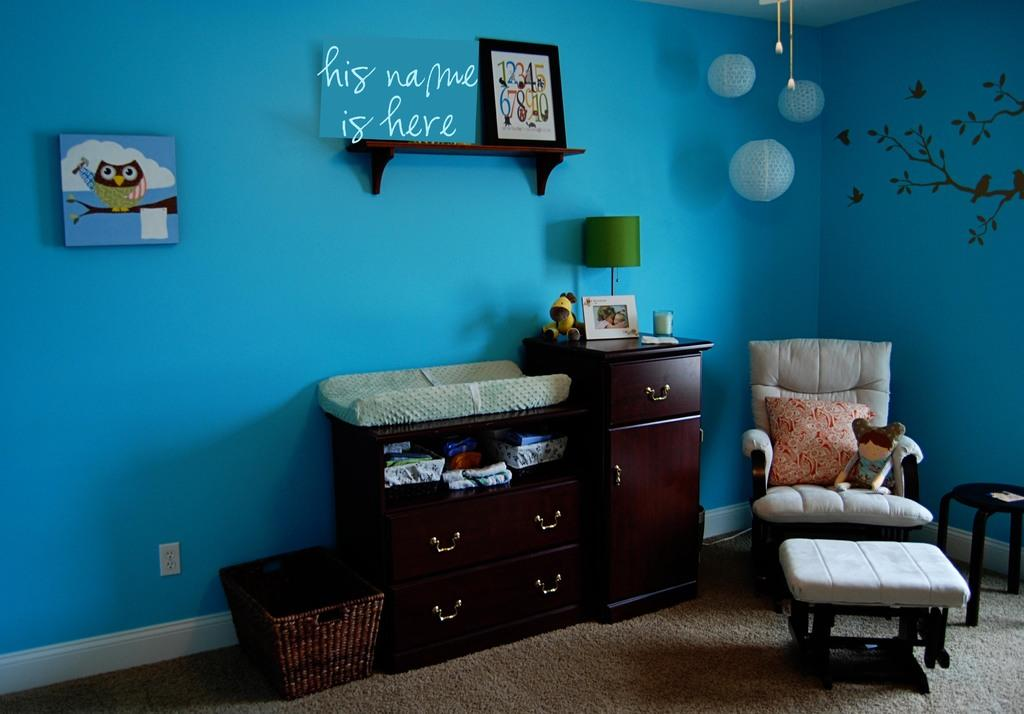<image>
Render a clear and concise summary of the photo. A blue wall with a shelf and the saying His Name Is Here. 